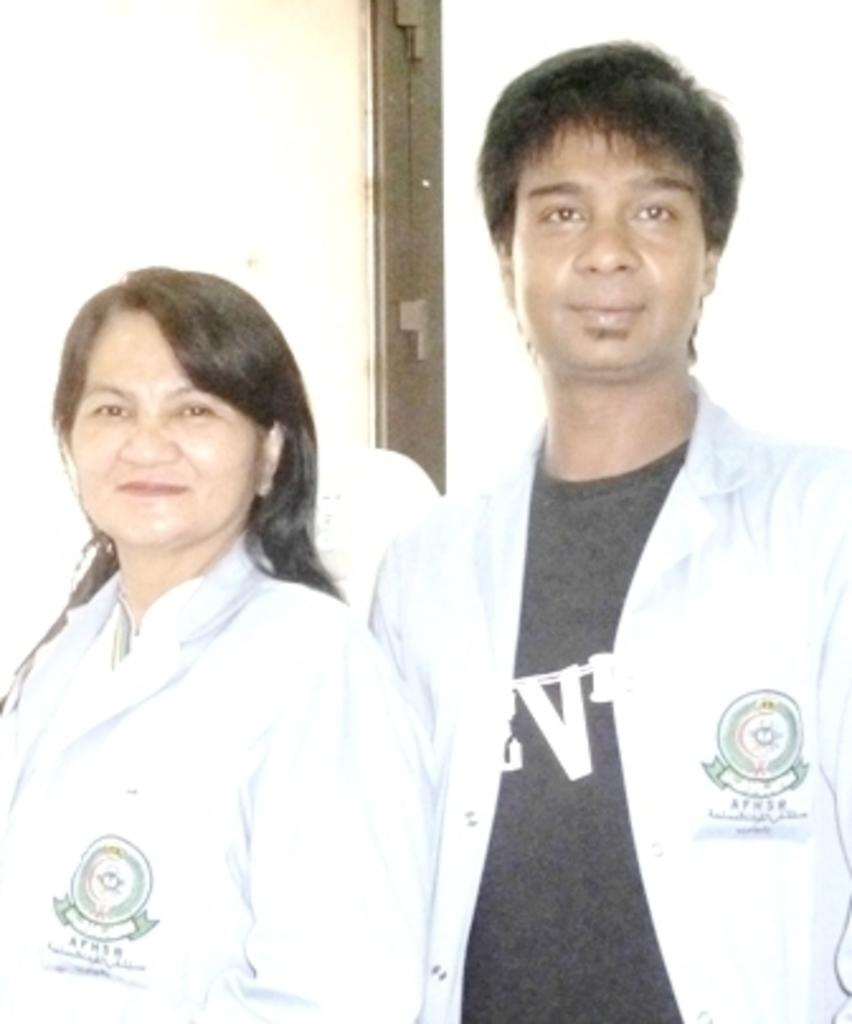How many people are present in the image? There are two people in the image. Can you describe the metallic object in the image? Unfortunately, the provided facts do not give any details about the metallic object, so we cannot describe it. How many hens are present in the image? There are no hens present in the image. What is the man in the image doing to get the attention of the other person? There is no man present in the image, and therefore no one is trying to get anyone's attention. 